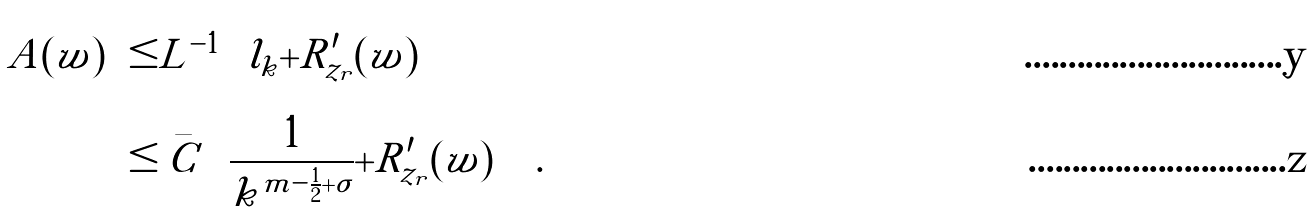<formula> <loc_0><loc_0><loc_500><loc_500>\| A ( w ) \| & \leq \| L ^ { - 1 } \| \left ( \| l _ { k } \| + \| R ^ { \prime } _ { z _ { r } } ( w ) \| \right ) \\ & \leq \bar { C } \left ( \frac { 1 } { k ^ { m - \frac { 1 } { 2 } + \sigma } } + \| R ^ { \prime } _ { z _ { r } } ( w ) \| \right ) .</formula> 